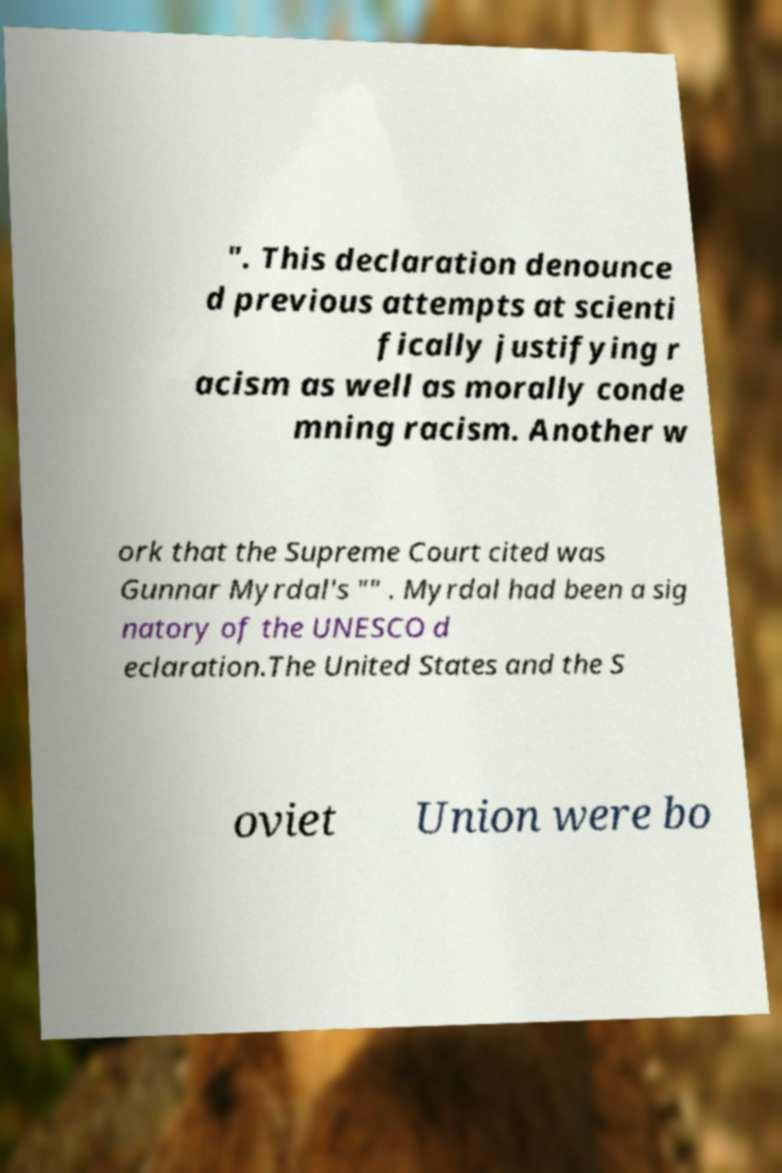Could you assist in decoding the text presented in this image and type it out clearly? ". This declaration denounce d previous attempts at scienti fically justifying r acism as well as morally conde mning racism. Another w ork that the Supreme Court cited was Gunnar Myrdal's "" . Myrdal had been a sig natory of the UNESCO d eclaration.The United States and the S oviet Union were bo 